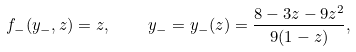Convert formula to latex. <formula><loc_0><loc_0><loc_500><loc_500>f _ { - } ( y _ { - } , z ) = z , \quad y _ { - } = y _ { - } ( z ) = \frac { 8 - 3 z - 9 z ^ { 2 } } { 9 ( 1 - z ) } ,</formula> 